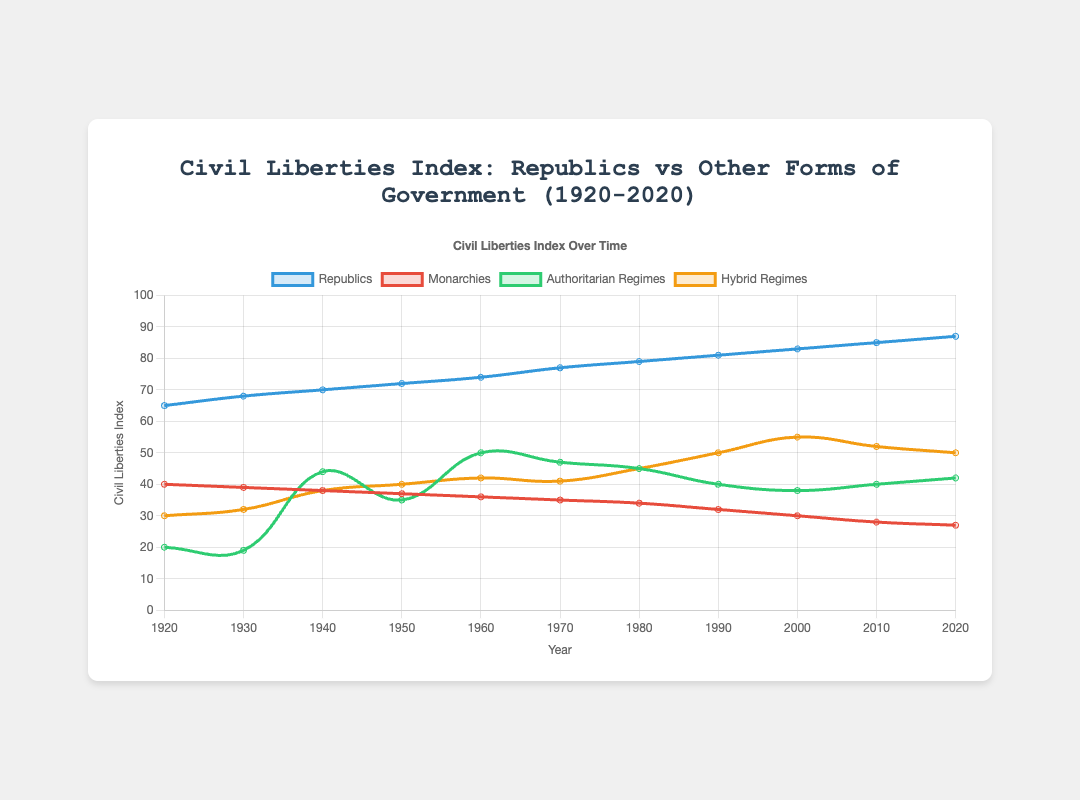What year did republics reach a Civil Liberties Index of 85? The blue curve representing republics reaches the value of 85 in the year 2010, as seen on the x-axis where the year intersects the value of 85 on the y-axis.
Answer: 2010 Which form of government had the lowest Civil Liberties Index in 1940? Comparing the curves at the year 1940, the green curve representing authoritarian regimes dips to around 44, the lowest among all the types shown.
Answer: Authoritarian regimes By how much did the Civil Liberties Index of hybrid regimes increase between 1920 and 2020? The orange curve representing hybrid regimes starts at 30 in 1920 and rises to 50 in 2020. The increase is 50 - 30 = 20.
Answer: 20 Identify the peak Civil Liberties Index value for monarchies in the given period. Observing the red curve, the highest point for monarchies occurs in 1920 with a value of 40.
Answer: 40 How did the Civil Liberties Index for authoritarian regimes change from 1930 to 1940? The green curve for authoritarian regimes rises from 19 in 1930 to 44 in 1940. The change is calculated as 44 - 19 = 25.
Answer: Increased by 25 Compare the Civil Liberties Index of republics and monarchies in 1970. In 1970, the blue curve for republics is at 77, while the red curve for monarchies is at 35. Thus, republics have a higher index than monarchies.
Answer: Republics have a higher index Which form of government shows the most consistent increase in the Civil Liberties Index over the century? Observing all the curves, the blue curve representing republics shows a steady and consistent increase from 65 in 1920 to 87 in 2020.
Answer: Republics What is the combined Civil Liberties Index of republics and hybrid regimes in the year 2000? In 2000, the indices are 83 for republics and 55 for hybrid regimes. Adding these values gives 83 + 55 = 138.
Answer: 138 How does the Civil Liberties Index of hybrid regimes in 2010 compare to that in 2000? The orange curve for hybrid regimes is at 55 in 2000 and at 52 in 2010. Thus, the index slightly decreases by 3 from 2000 to 2010.
Answer: Decreased by 3 Which form of government showed an increase in the Civil Liberties Index between 2010 and 2020? Comparing the endpoints of all the curves, only the blue curve for republics shows an increase, from 85 in 2010 to 87 in 2020.
Answer: Republics 